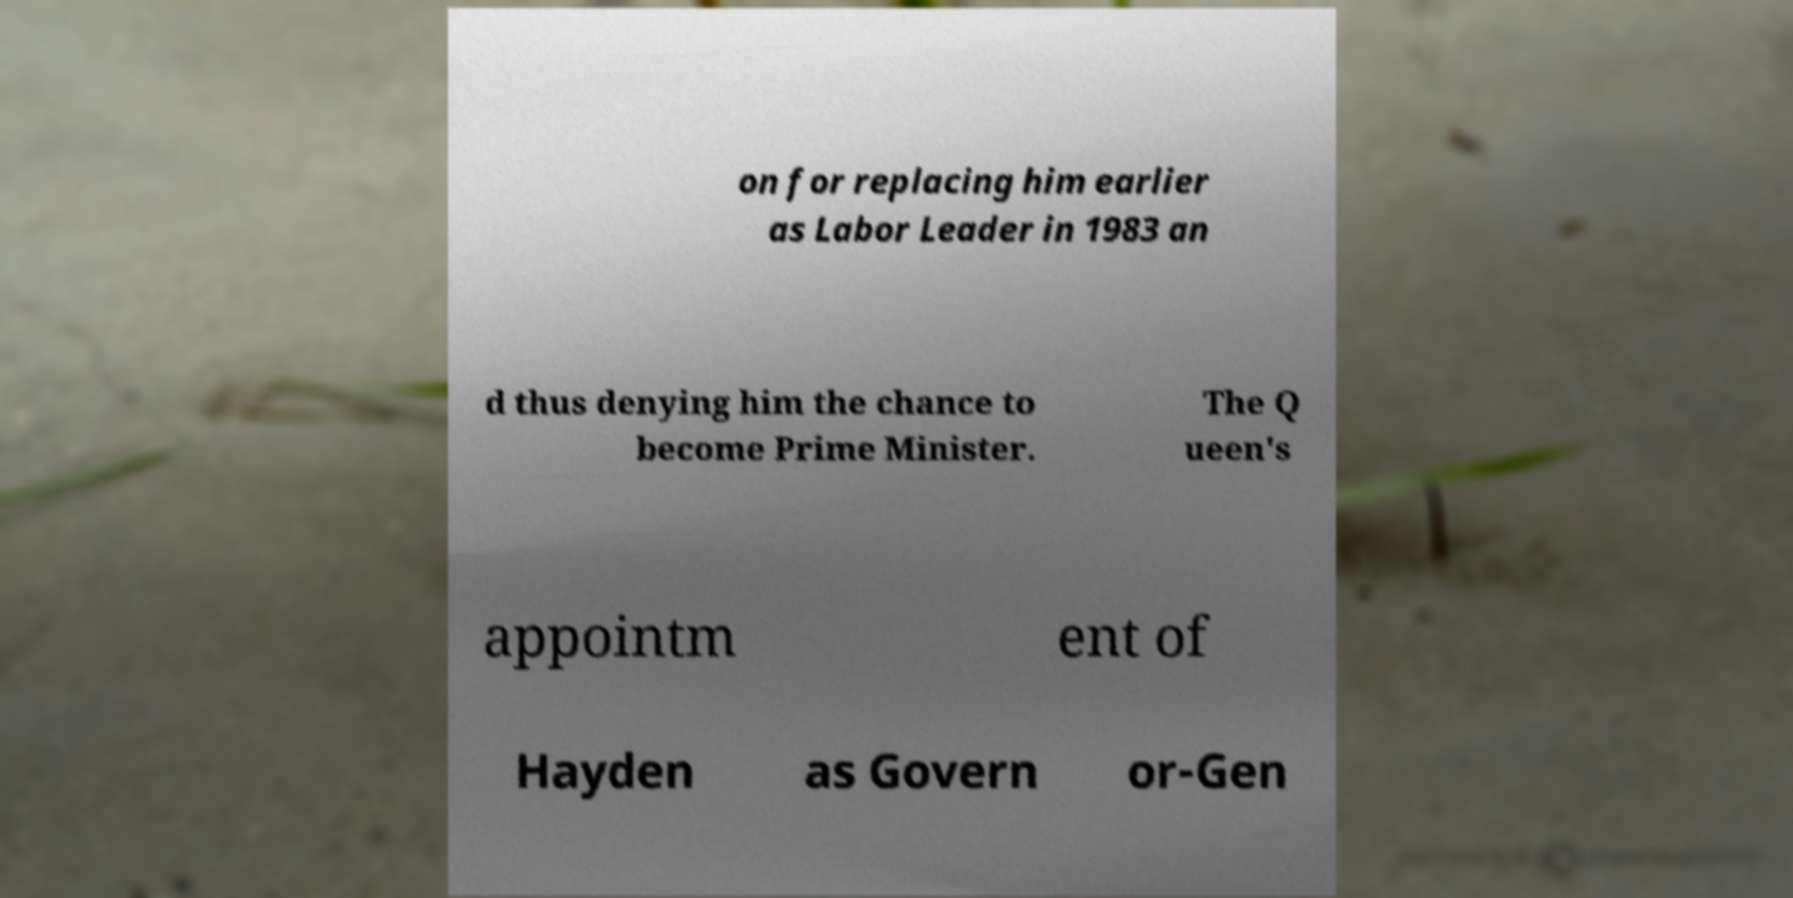Can you accurately transcribe the text from the provided image for me? on for replacing him earlier as Labor Leader in 1983 an d thus denying him the chance to become Prime Minister. The Q ueen's appointm ent of Hayden as Govern or-Gen 